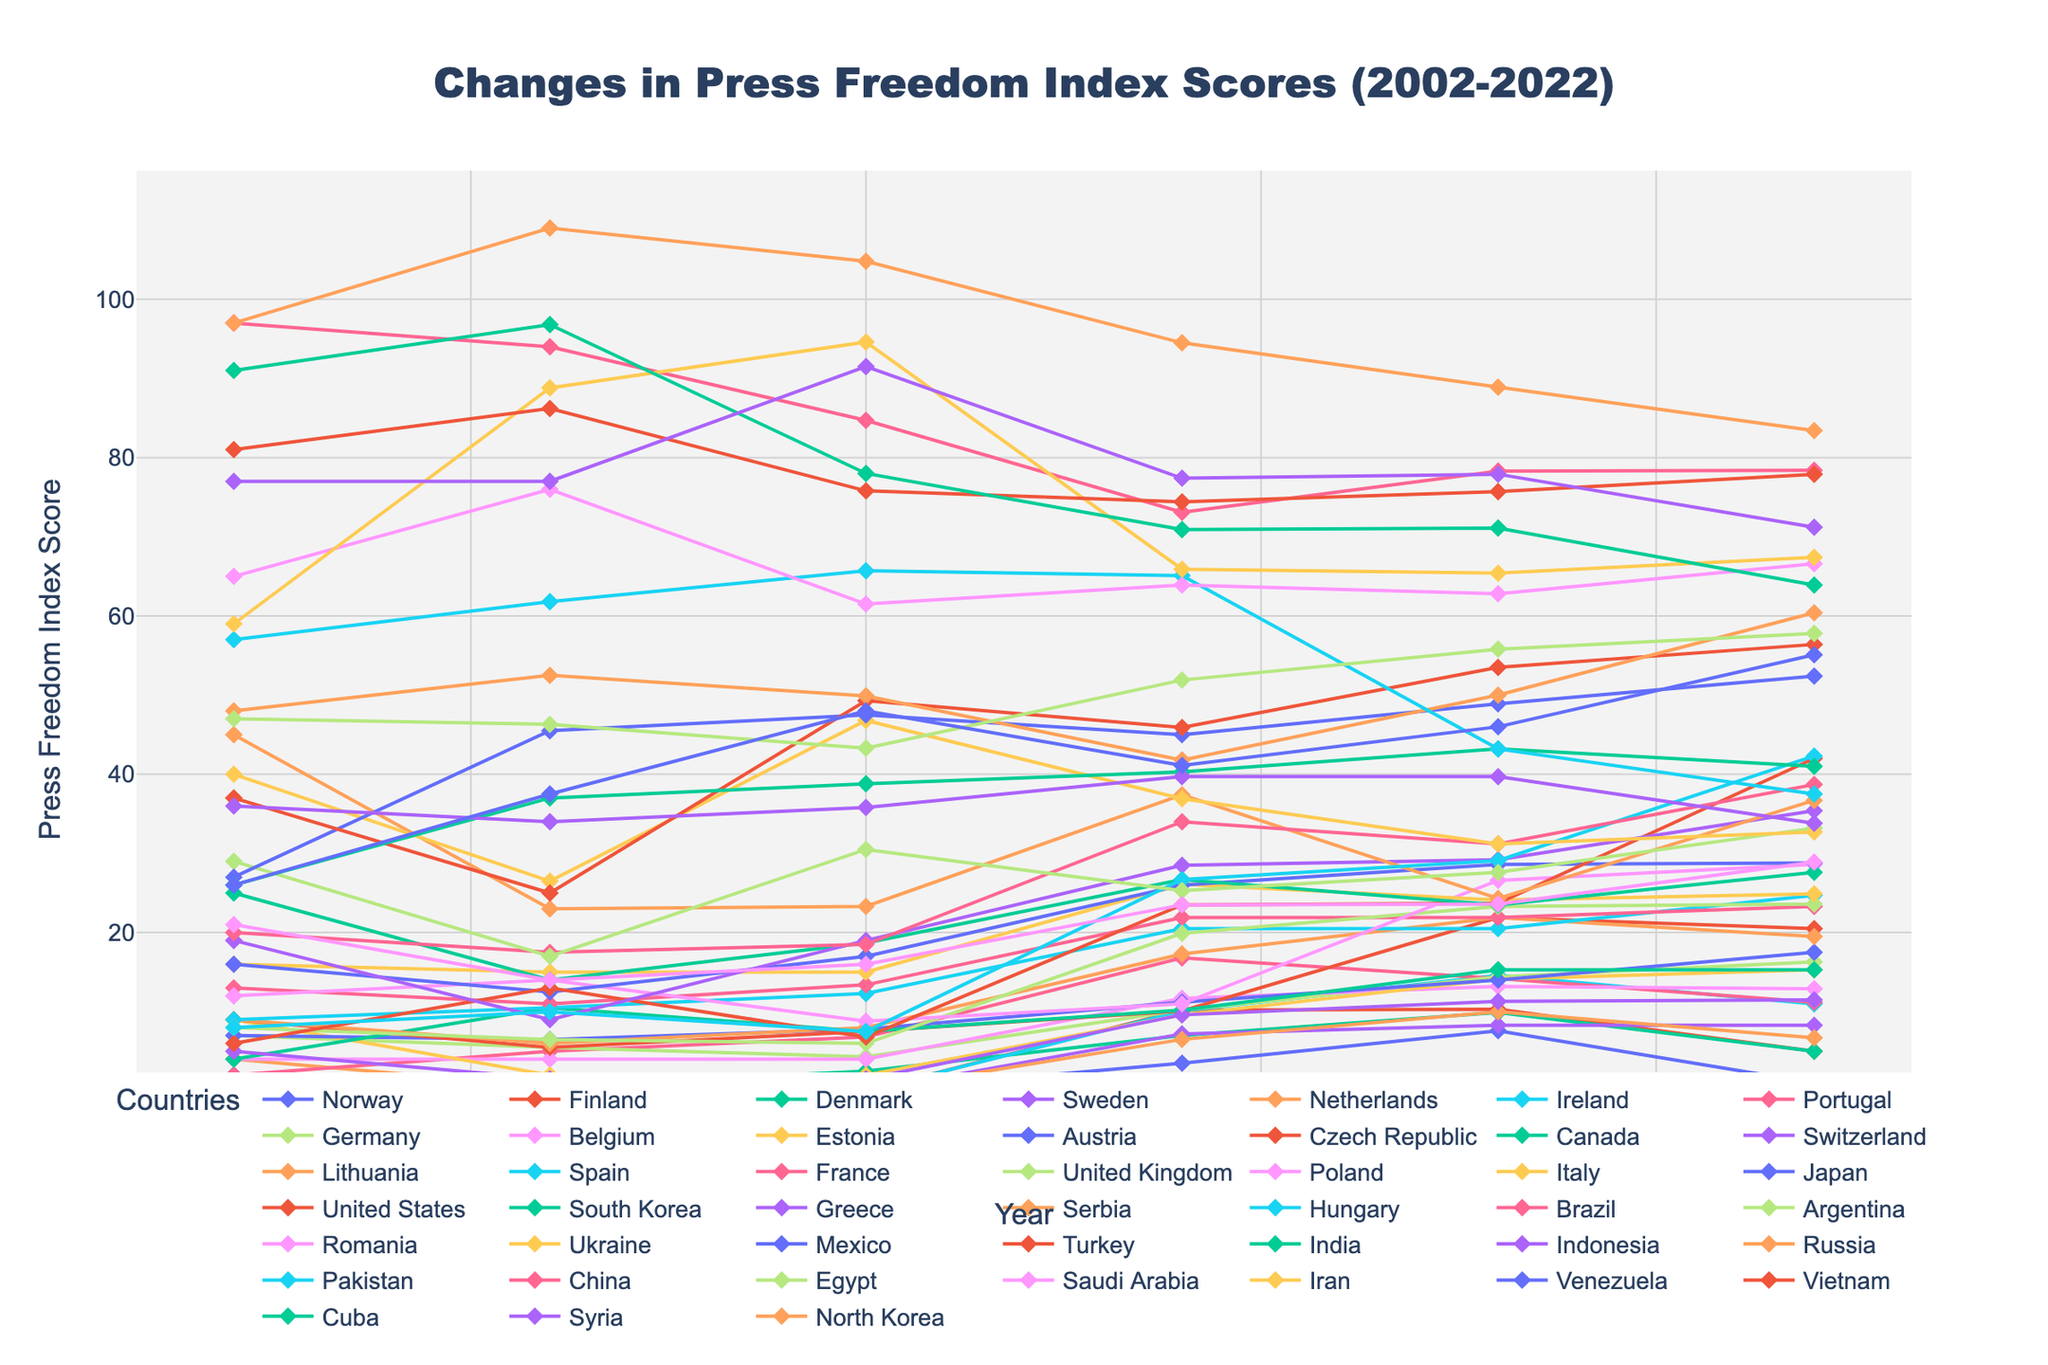Which country has had the most significant improvement in press freedom between 2018 and 2022? To find the answer, we compare the scores from 2018 and 2022 and look for the largest decrease, indicating an improvement in press freedom. Norway's score decreased from 7.6 to 1.0, showing a significant improvement.
Answer: Norway Which country’s press freedom score showed the most consistent decline over the 20-year period? We need to identify the country that showed a consistent increase in its press freedom index score across all years. North Korea's scores steadily increased from 97.0 in 2002 to 109.0, 104.8, 94.5, 88.9, and finally 83.4 in 2022.
Answer: North Korea What is the average press freedom score for Denmark over these years (2002-2022)? Sum up Denmark's scores from the years 2002, 2006, 2010, 2014, 2018, and 2022, then divide by the number of data points: (1.0 + 0.5 + 2.5 + 7.0 + 9.9 + 5.0)/6 = 4.32
Answer: 4.32 Which country had the highest press freedom index in 2022 and what is its score? Examine the 2022 scores and identify the highest one. North Korea has the highest score with 83.4
Answer: North Korea, 83.4 How many countries had their press freedom score improve from 2018 to 2022? We count the number of countries where the score decreased from 2018 to 2022: Norway, Finland, Denmark, Ireland, Portugal, Netherlands, India, and Pakistan. 8 countries improved their press freedom score.
Answer: 8 Which five countries had the best press freedom score in 2014 and what were the scores? Check the 2014 data and pick the five countries with the lowest scores: Finland (10.2), Ireland (10.1), Czech Republic (10.1), Germany (10.2), and Canada (10.2).
Answer: Finland 10.2, Ireland 10.1, Czech Republic 10.1, Germany 10.2, Canada 10.2 Which country showed the largest deterioration in press freedom between 2002 and 2022? Compare the changes in scores from 2002 to 2022 for each country and find the largest increase. The United States score increased from 6.0 to 42.0, showing the largest deterioration.
Answer: United States What is the median press freedom score for all countries in 2018? To find the median, we list all the 2018 scores in numerical order and find the middle value(s). The middle score(s) are 29.1 and 29.2, so the median is the average of these two values: (29.1 + 29.2)/2 = 29.15
Answer: 29.15 How did press freedom in China and Russia change from 2002 to 2022? We compare China and Russia’s scores over the years. China's score changed from 97.0 to 78.4, showing a slight improvement. Russia's score changed from 48.0 to 60.4, indicating deterioration.
Answer: China improved, Russia deteriorated 